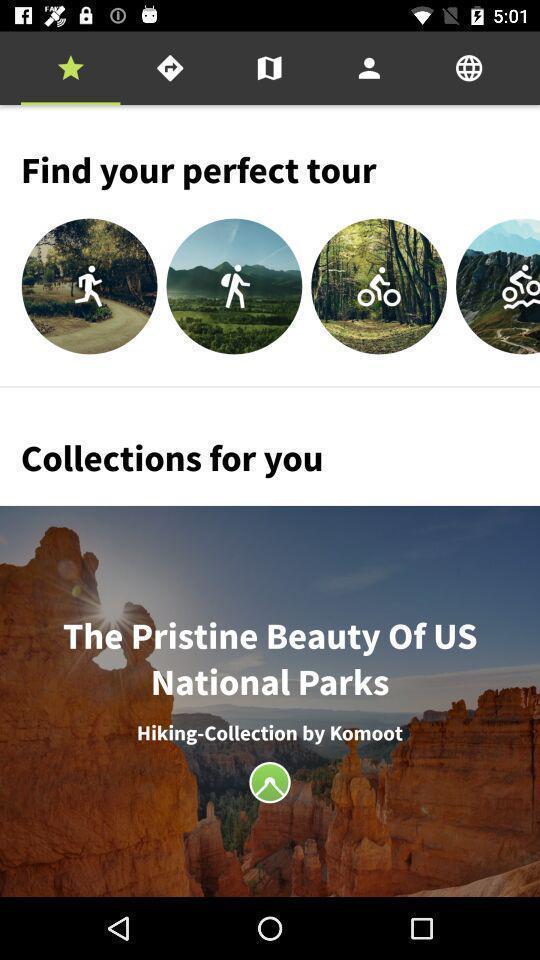Describe the content in this image. Various activities displayed of a travel app. 